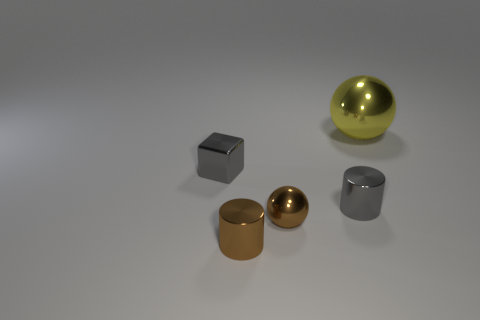Add 1 large yellow metallic balls. How many objects exist? 6 Subtract all green cylinders. Subtract all brown blocks. How many cylinders are left? 2 Subtract all green blocks. How many gray cylinders are left? 1 Subtract all large gray shiny blocks. Subtract all brown things. How many objects are left? 3 Add 3 small gray cubes. How many small gray cubes are left? 4 Add 1 large blue cylinders. How many large blue cylinders exist? 1 Subtract 0 gray balls. How many objects are left? 5 Subtract all cylinders. How many objects are left? 3 